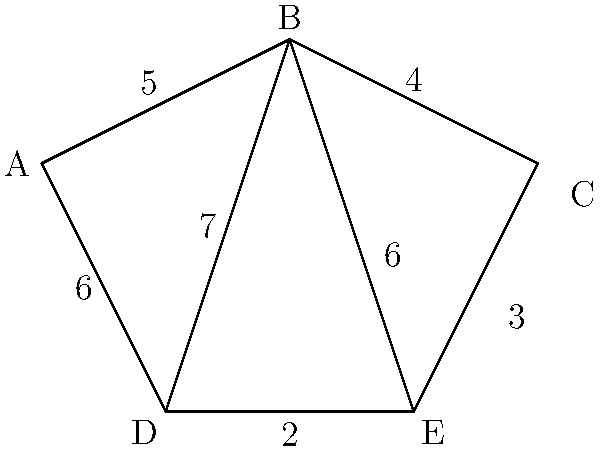In the given network infrastructure map, nodes represent VoIP servers and edges represent data transmission paths with their respective latencies (in milliseconds). If you need to transmit data from server A to server C, what is the shortest possible route in terms of total latency? To solve this problem, we need to consider all possible paths from A to C and calculate their total latencies:

1. Path A-B-C:
   A to B: 5 ms
   B to C: 4 ms
   Total: 5 + 4 = 9 ms

2. Path A-D-B-C:
   A to D: 6 ms
   D to B: 7 ms
   B to C: 4 ms
   Total: 6 + 7 + 4 = 17 ms

3. Path A-D-E-C:
   A to D: 6 ms
   D to E: 2 ms
   E to C: 3 ms
   Total: 6 + 2 + 3 = 11 ms

4. Path A-B-E-C:
   A to B: 5 ms
   B to E: 6 ms
   E to C: 3 ms
   Total: 5 + 6 + 3 = 14 ms

Comparing all these paths, we can see that the shortest route in terms of total latency is path A-B-C with a total latency of 9 ms.
Answer: A-B-C (9 ms) 